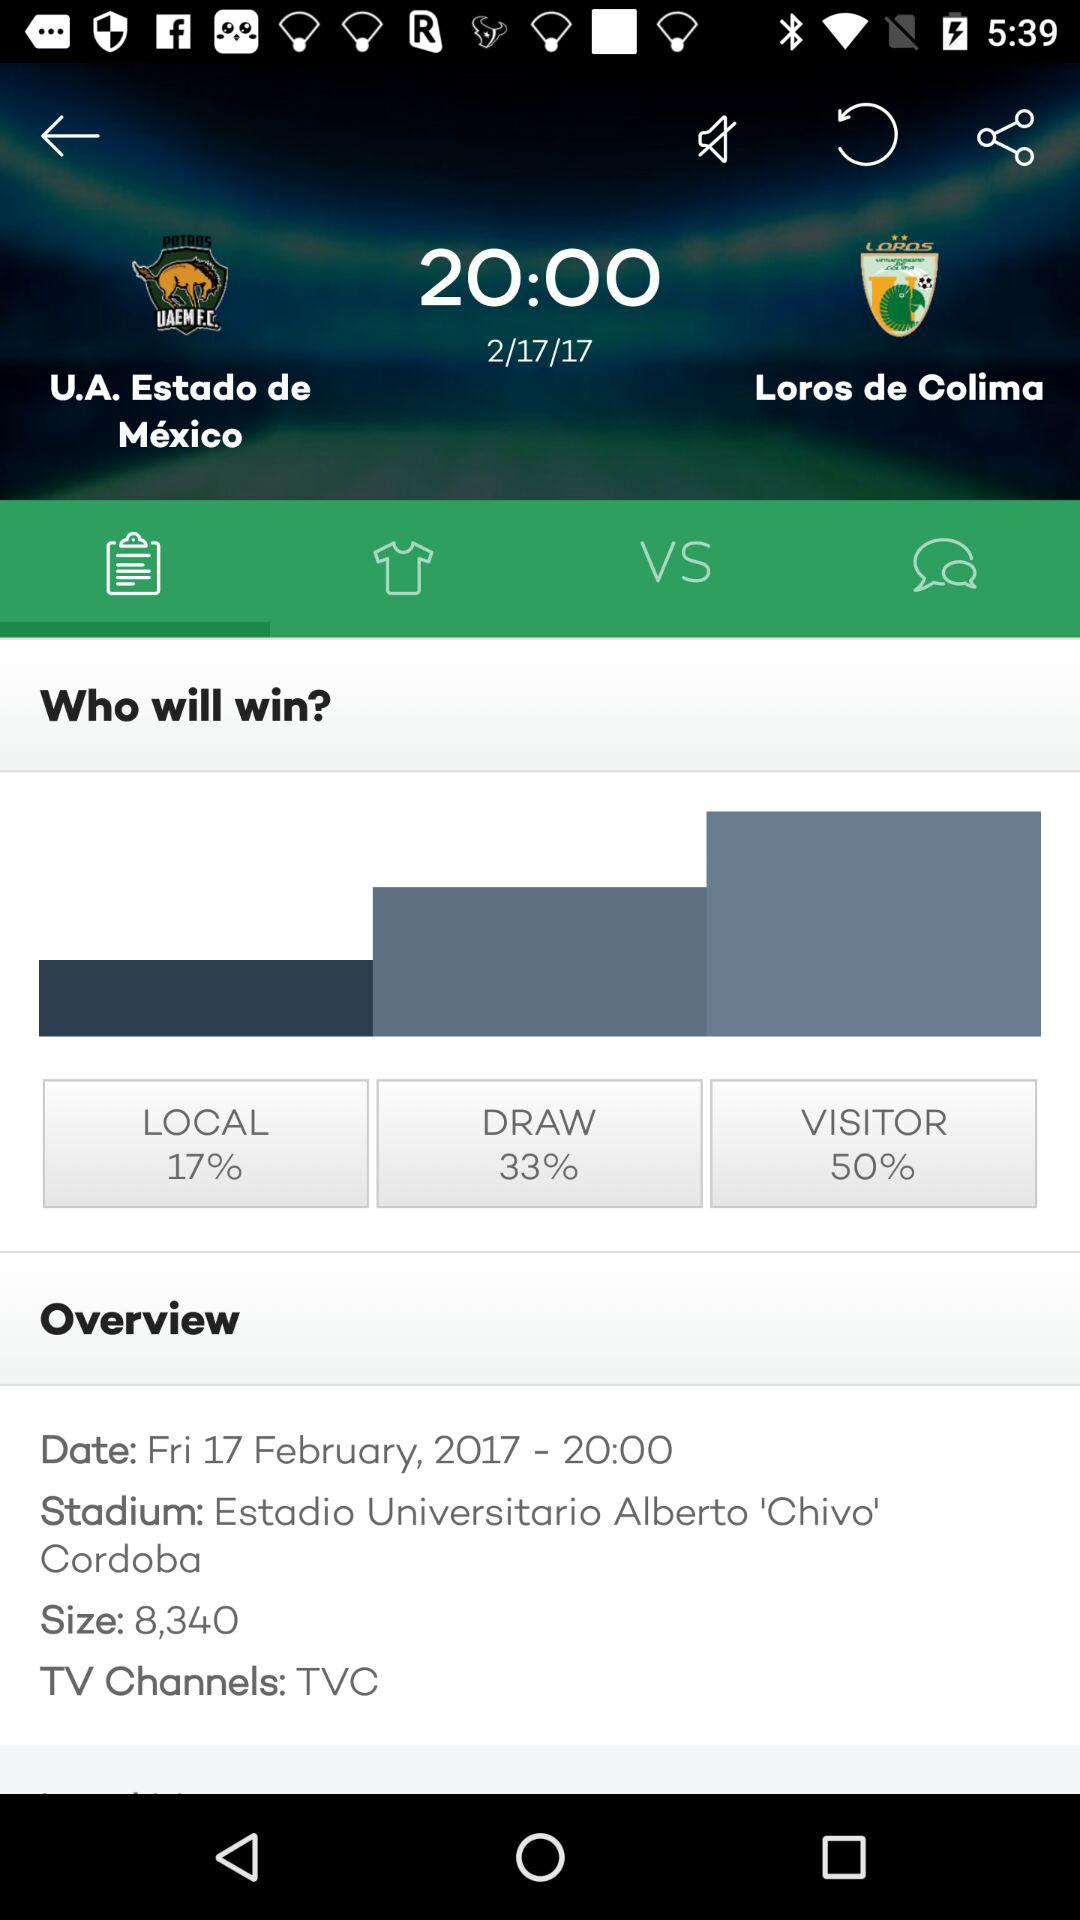What stadium is the match going to be at? The match is going to be at Estadio Universitario Alberto 'Chivo' Cordoba. 